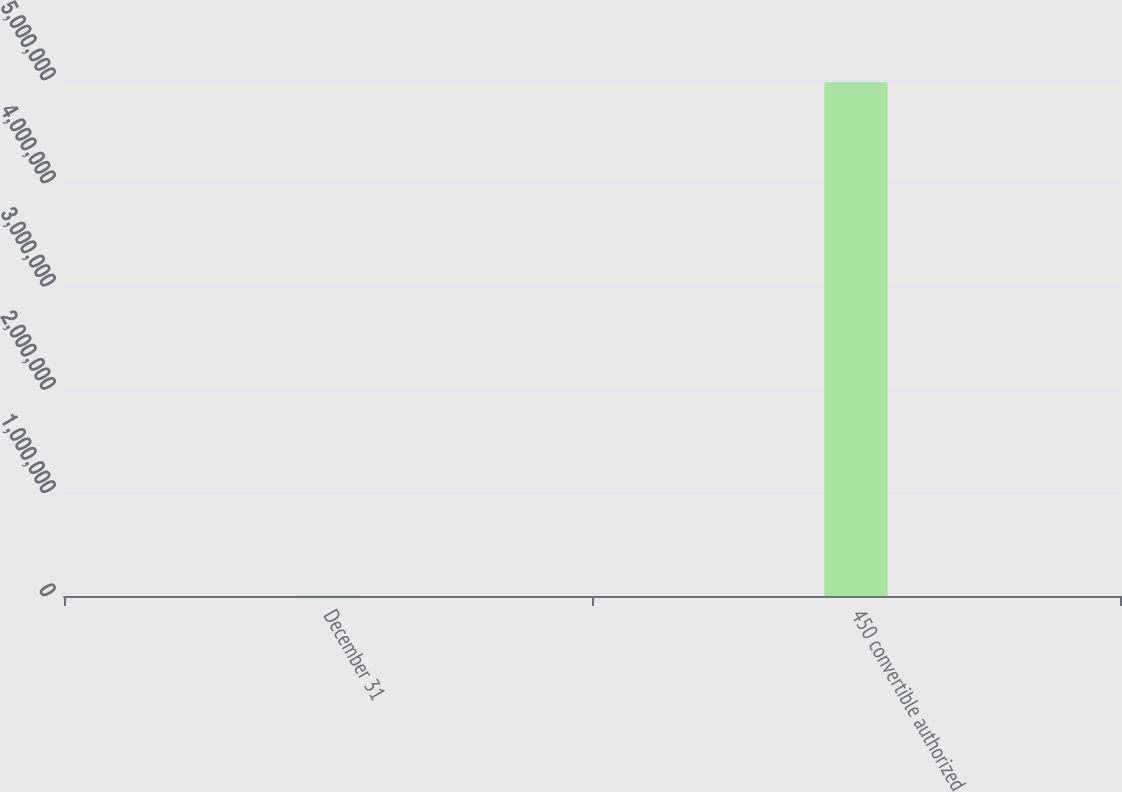<chart> <loc_0><loc_0><loc_500><loc_500><bar_chart><fcel>December 31<fcel>450 convertible authorized<nl><fcel>2008<fcel>4.978e+06<nl></chart> 